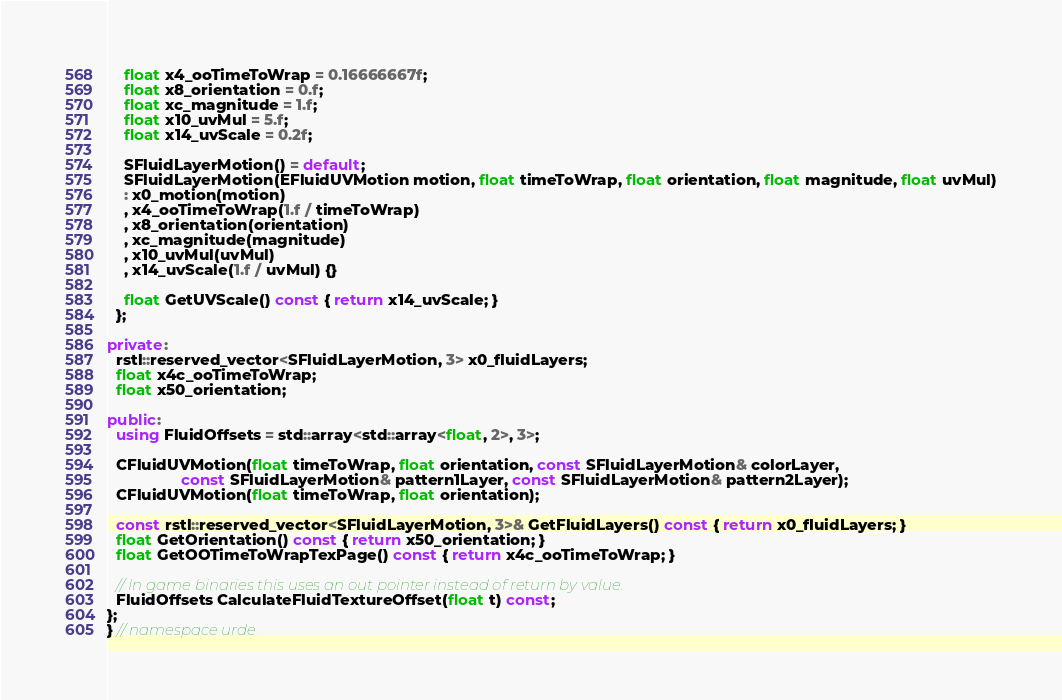<code> <loc_0><loc_0><loc_500><loc_500><_C++_>    float x4_ooTimeToWrap = 0.16666667f;
    float x8_orientation = 0.f;
    float xc_magnitude = 1.f;
    float x10_uvMul = 5.f;
    float x14_uvScale = 0.2f;

    SFluidLayerMotion() = default;
    SFluidLayerMotion(EFluidUVMotion motion, float timeToWrap, float orientation, float magnitude, float uvMul)
    : x0_motion(motion)
    , x4_ooTimeToWrap(1.f / timeToWrap)
    , x8_orientation(orientation)
    , xc_magnitude(magnitude)
    , x10_uvMul(uvMul)
    , x14_uvScale(1.f / uvMul) {}

    float GetUVScale() const { return x14_uvScale; }
  };

private:
  rstl::reserved_vector<SFluidLayerMotion, 3> x0_fluidLayers;
  float x4c_ooTimeToWrap;
  float x50_orientation;

public:
  using FluidOffsets = std::array<std::array<float, 2>, 3>;

  CFluidUVMotion(float timeToWrap, float orientation, const SFluidLayerMotion& colorLayer,
                 const SFluidLayerMotion& pattern1Layer, const SFluidLayerMotion& pattern2Layer);
  CFluidUVMotion(float timeToWrap, float orientation);

  const rstl::reserved_vector<SFluidLayerMotion, 3>& GetFluidLayers() const { return x0_fluidLayers; }
  float GetOrientation() const { return x50_orientation; }
  float GetOOTimeToWrapTexPage() const { return x4c_ooTimeToWrap; }

  // In game binaries this uses an out pointer instead of return by value.
  FluidOffsets CalculateFluidTextureOffset(float t) const;
};
} // namespace urde
</code> 